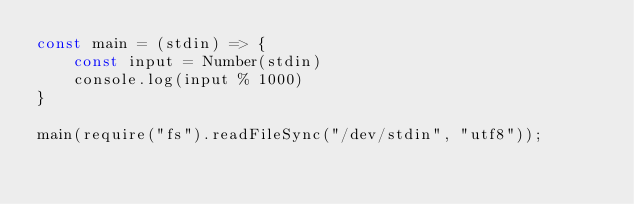<code> <loc_0><loc_0><loc_500><loc_500><_JavaScript_>const main = (stdin) => {
    const input = Number(stdin)
    console.log(input % 1000)
}
 
main(require("fs").readFileSync("/dev/stdin", "utf8"));</code> 